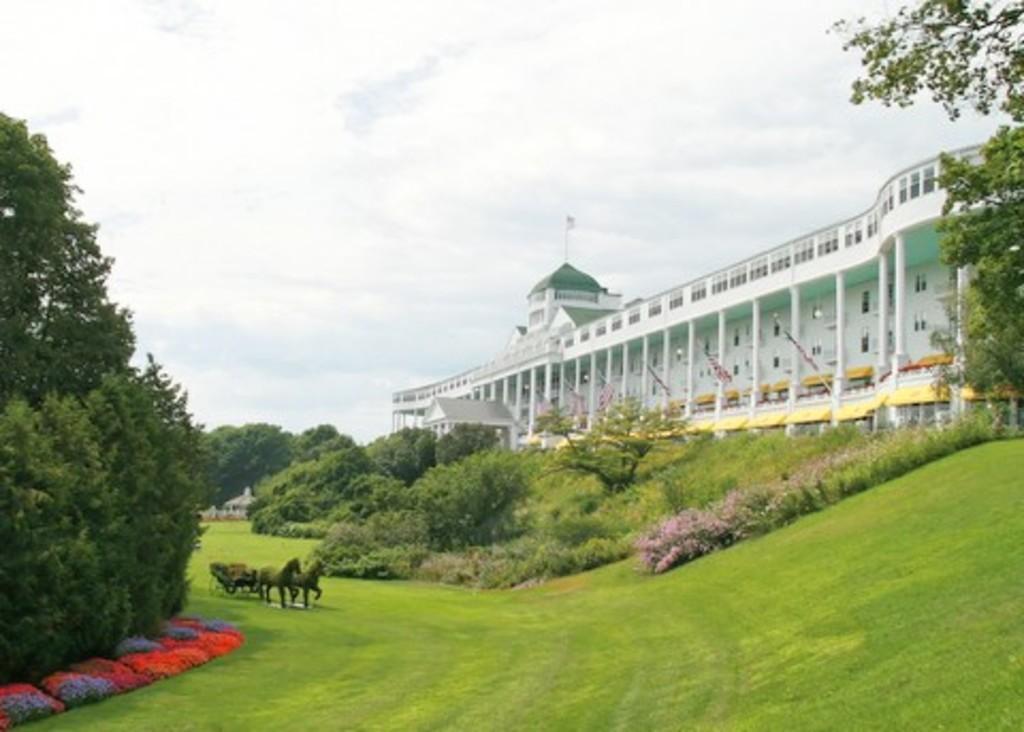Can you describe this image briefly? In this picture we can see horses, cart, plants, grass, flowers, trees, building, flags and shed. In the background of the image we can see the sky with clouds. 